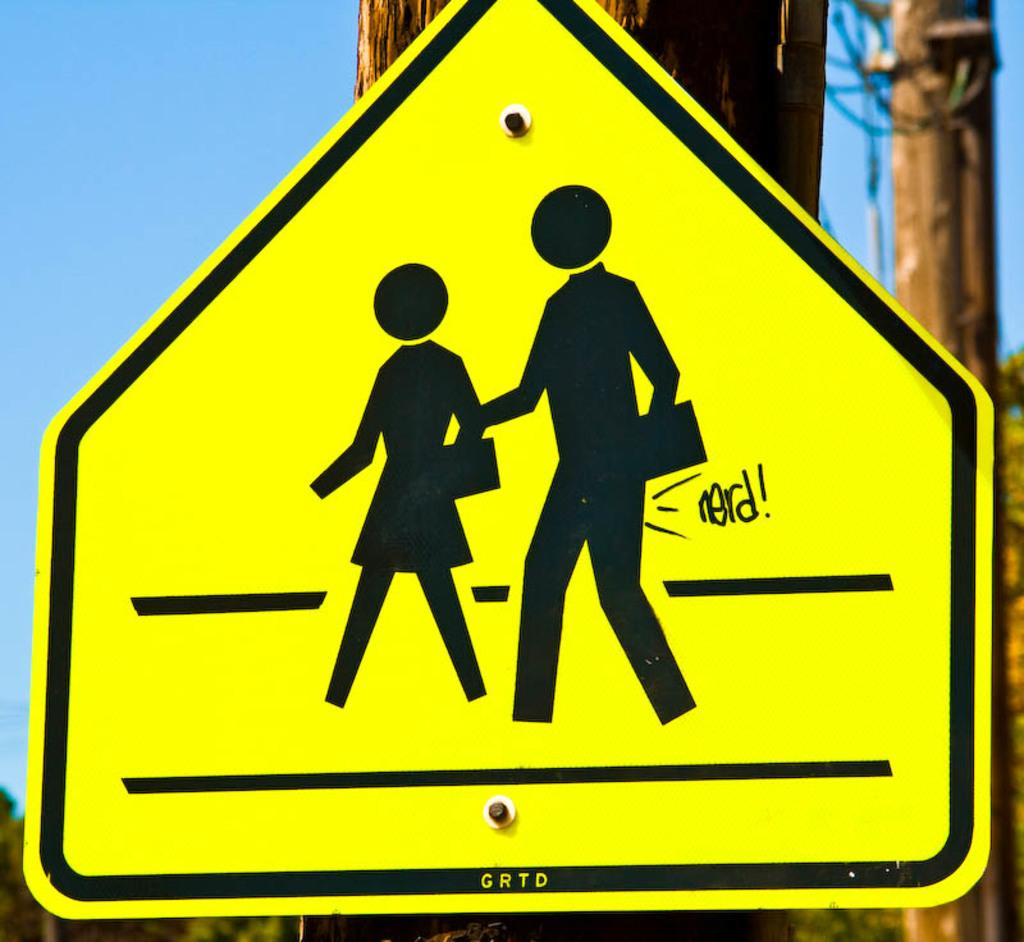<image>
Share a concise interpretation of the image provided. A school crossing sign has been vandalized with the word nerd behind one of the children. 